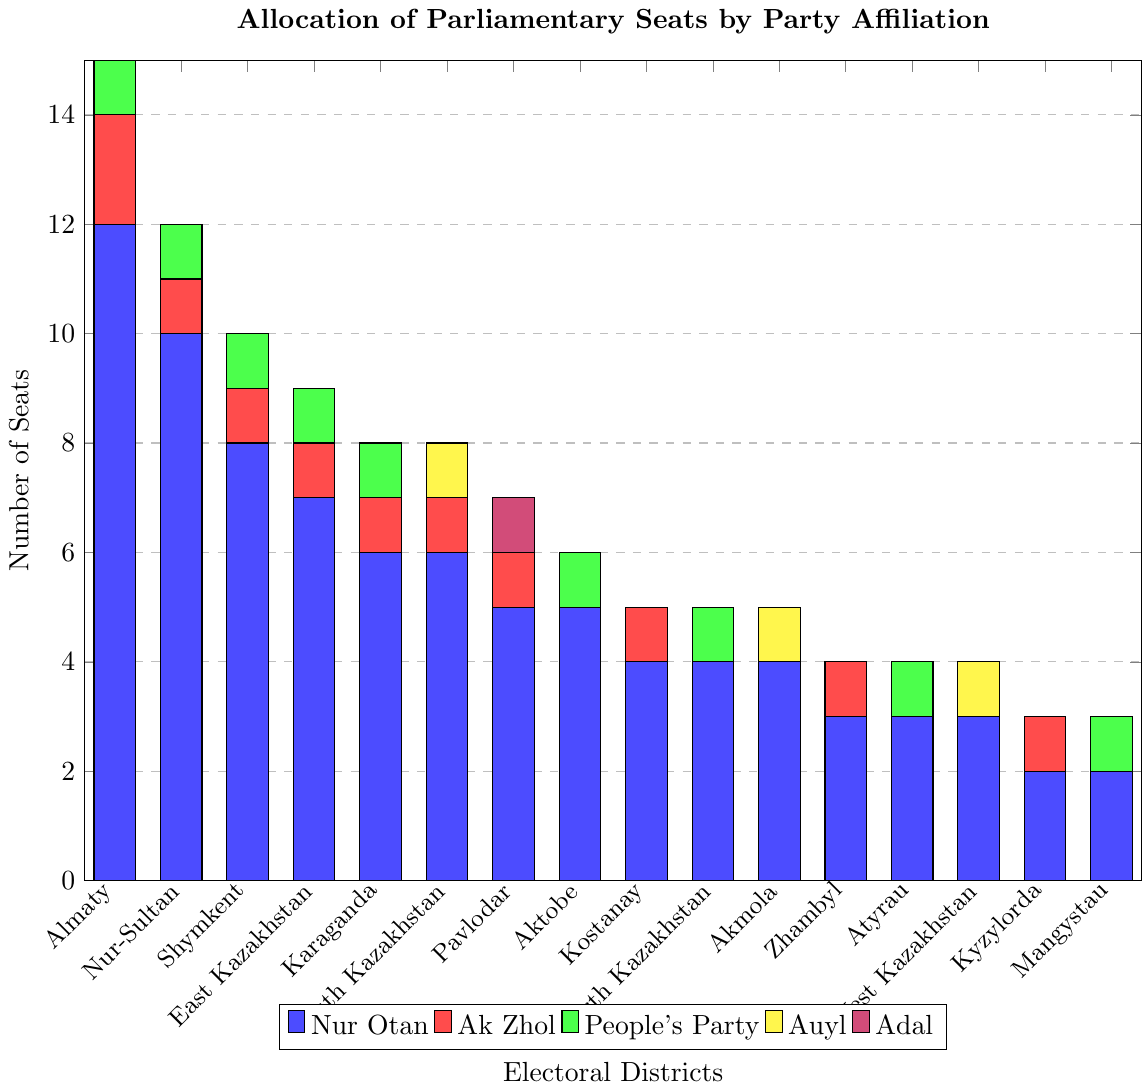What is the total number of seats allocated to Nur Otan across all districts? Sum the values of the blue bars representing Nur Otan across all districts: 12 + 10 + 8 + 7 + 6 + 6 + 5 + 5 + 4 + 4 + 4 + 3 + 3 + 3 + 2 + 2 = 84
Answer: 84 Which party has the least number of seats in the Almaty district? Observe the height of the bars in the Almaty district, the smallest bar corresponds to both Auyl (yellow) and Adal (purple) with 0 seats each
Answer: Auyl, Adal How many seats does Ak Zhol have in Nur-Sultan and Shymkent combined? Sum the values of the red bars representing Ak Zhol in Nur-Sultan and Shymkent: 1 + 1 = 2
Answer: 2 Which district has the highest number of seats allocated to Auyl? Look at the yellow bars representing Auyl and identify the highest one in South Kazakhstan and West Kazakhstan, each with 1 seat. Therefore, South Kazakhstan is one of them.
Answer: South Kazakhstan What is the difference in the number of seats between Nur Otan and Adal in Pavlodar? Subtract the value of the purple bar (Adal) from the blue bar (Nur Otan) in Pavlodar: 5 - 1 = 4
Answer: 4 Which district has the highest total number of parliamentary seats? Sum the total values of seats for all parties in each district and identify the highest. Almaty: 12 + 2 + 1 + 0 + 0 = 15, Nur-Sultan: 10 + 1 + 1 + 0 + 0 = 12, etc. The highest total is in Almaty with 15 seats.
Answer: Almaty What is the median number of seats allocated to Nur Otan across all districts? List the values in order: 2, 2, 3, 3, 3, 4, 4, 4, 5, 5, 6, 6, 7, 8, 10, 12. The median is (4+4)/2 = 4.
Answer: 4 How many districts have no seats allocated to Adal? Count the number of districts where the purple bar representing Adal is 0: Nur-Sultan, Shymkent, East Kazakhstan, Karaganda, South Kazakhstan, Aktobe, Kostanay, North Kazakhstan, Akmola, Zhambyl, Atyrau, West Kazakhstan, Kyzylorda, Mangystau. There are 14 such districts.
Answer: 14 Which party has seats in the most districts? Compare the number of districts each party is present in by observing the bars: Nur Otan appears in all 16 districts, making it the party present in the most districts.
Answer: Nur Otan What is the range of seats allocated to People's Party across all districts? Identify the minimum and maximum values of the green bars representing People's Party: the minimum is 0 (several districts), and the maximum is 1. The range is 1 - 0 = 1.
Answer: 1 